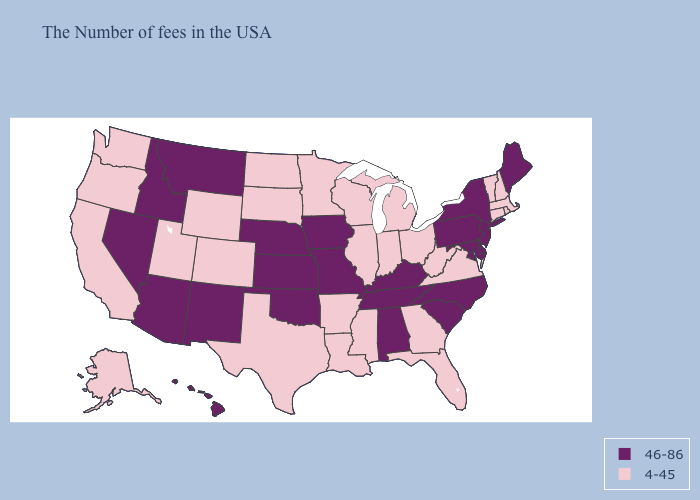Name the states that have a value in the range 46-86?
Short answer required. Maine, New York, New Jersey, Delaware, Maryland, Pennsylvania, North Carolina, South Carolina, Kentucky, Alabama, Tennessee, Missouri, Iowa, Kansas, Nebraska, Oklahoma, New Mexico, Montana, Arizona, Idaho, Nevada, Hawaii. Does Georgia have the same value as Mississippi?
Concise answer only. Yes. What is the highest value in the MidWest ?
Keep it brief. 46-86. Name the states that have a value in the range 4-45?
Short answer required. Massachusetts, Rhode Island, New Hampshire, Vermont, Connecticut, Virginia, West Virginia, Ohio, Florida, Georgia, Michigan, Indiana, Wisconsin, Illinois, Mississippi, Louisiana, Arkansas, Minnesota, Texas, South Dakota, North Dakota, Wyoming, Colorado, Utah, California, Washington, Oregon, Alaska. Among the states that border Alabama , which have the lowest value?
Concise answer only. Florida, Georgia, Mississippi. Does the map have missing data?
Write a very short answer. No. What is the value of Wisconsin?
Write a very short answer. 4-45. Name the states that have a value in the range 4-45?
Concise answer only. Massachusetts, Rhode Island, New Hampshire, Vermont, Connecticut, Virginia, West Virginia, Ohio, Florida, Georgia, Michigan, Indiana, Wisconsin, Illinois, Mississippi, Louisiana, Arkansas, Minnesota, Texas, South Dakota, North Dakota, Wyoming, Colorado, Utah, California, Washington, Oregon, Alaska. Does the first symbol in the legend represent the smallest category?
Short answer required. No. What is the lowest value in the USA?
Give a very brief answer. 4-45. Among the states that border Virginia , which have the highest value?
Short answer required. Maryland, North Carolina, Kentucky, Tennessee. What is the highest value in the USA?
Give a very brief answer. 46-86. Which states have the lowest value in the MidWest?
Give a very brief answer. Ohio, Michigan, Indiana, Wisconsin, Illinois, Minnesota, South Dakota, North Dakota. Name the states that have a value in the range 4-45?
Short answer required. Massachusetts, Rhode Island, New Hampshire, Vermont, Connecticut, Virginia, West Virginia, Ohio, Florida, Georgia, Michigan, Indiana, Wisconsin, Illinois, Mississippi, Louisiana, Arkansas, Minnesota, Texas, South Dakota, North Dakota, Wyoming, Colorado, Utah, California, Washington, Oregon, Alaska. What is the value of Idaho?
Concise answer only. 46-86. 